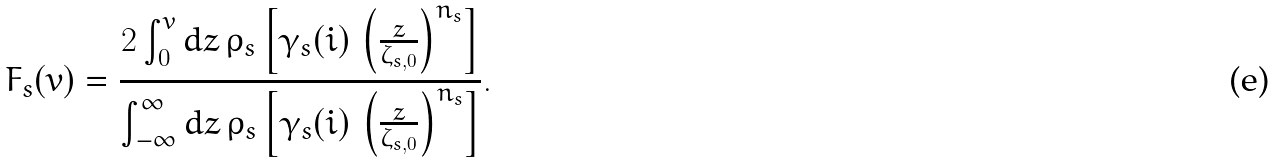Convert formula to latex. <formula><loc_0><loc_0><loc_500><loc_500>F _ { s } ( v ) = { \frac { 2 \int _ { 0 } ^ { v } d z \, \rho _ { s } \left [ \gamma _ { s } ( i ) \, \left ( { \frac { z } { \zeta _ { s , 0 } } } \right ) ^ { n _ { s } } \right ] } { \int _ { - \infty } ^ { \infty } d z \, \rho _ { s } \left [ \gamma _ { s } ( i ) \, \left ( { \frac { z } { \zeta _ { s , 0 } } } \right ) ^ { n _ { s } } \right ] } } .</formula> 